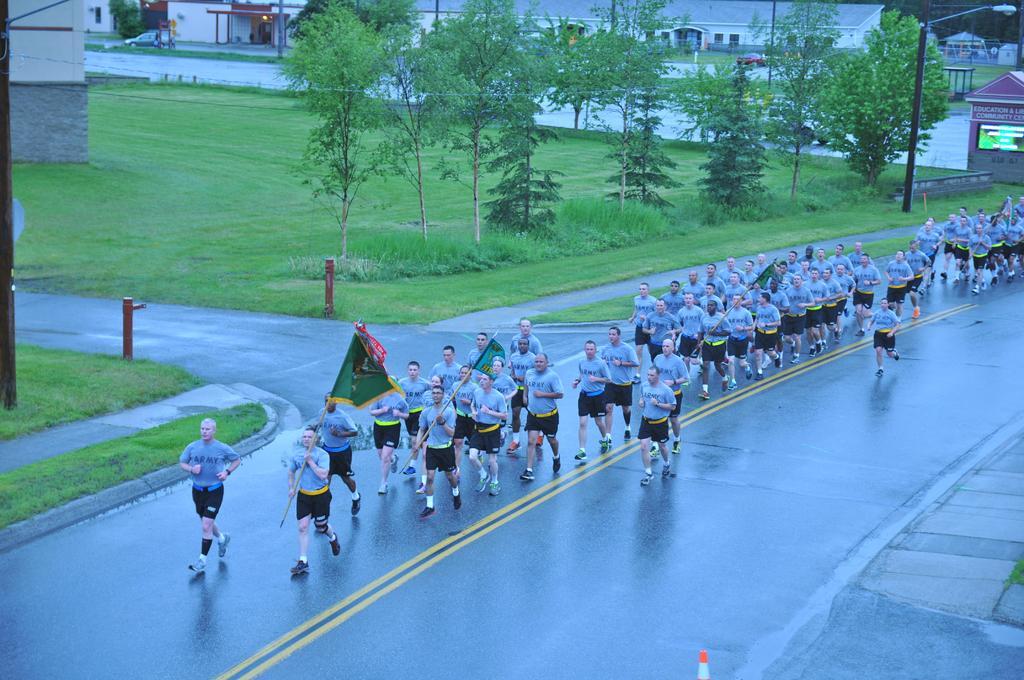In one or two sentences, can you explain what this image depicts? To the bottom of the image there is a road. On the road there are many people with blue t-shirt and black short is walking on the roads with holding the flags in their hands. And behind them in the background. on the ground there is a grass, plants and trees. And also there are buildings with roofs, windows, walls and pillars and also there are few cars and poles with street lights. 